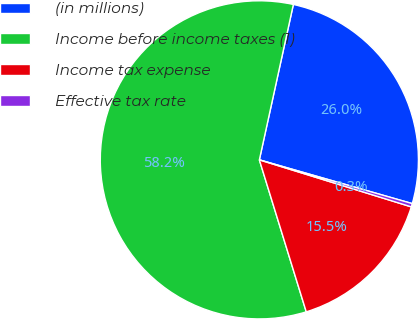<chart> <loc_0><loc_0><loc_500><loc_500><pie_chart><fcel>(in millions)<fcel>Income before income taxes (1)<fcel>Income tax expense<fcel>Effective tax rate<nl><fcel>26.01%<fcel>58.2%<fcel>15.46%<fcel>0.34%<nl></chart> 